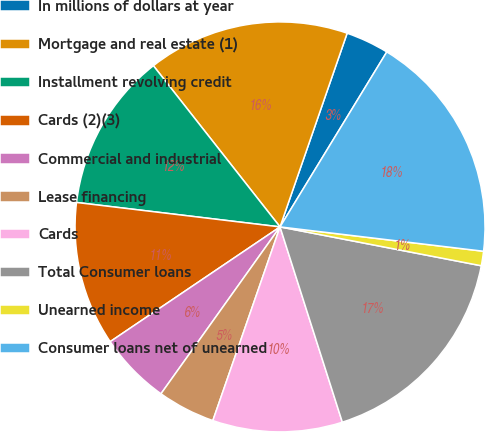<chart> <loc_0><loc_0><loc_500><loc_500><pie_chart><fcel>In millions of dollars at year<fcel>Mortgage and real estate (1)<fcel>Installment revolving credit<fcel>Cards (2)(3)<fcel>Commercial and industrial<fcel>Lease financing<fcel>Cards<fcel>Total Consumer loans<fcel>Unearned income<fcel>Consumer loans net of unearned<nl><fcel>3.41%<fcel>15.91%<fcel>12.5%<fcel>11.36%<fcel>5.68%<fcel>4.55%<fcel>10.23%<fcel>17.05%<fcel>1.14%<fcel>18.18%<nl></chart> 